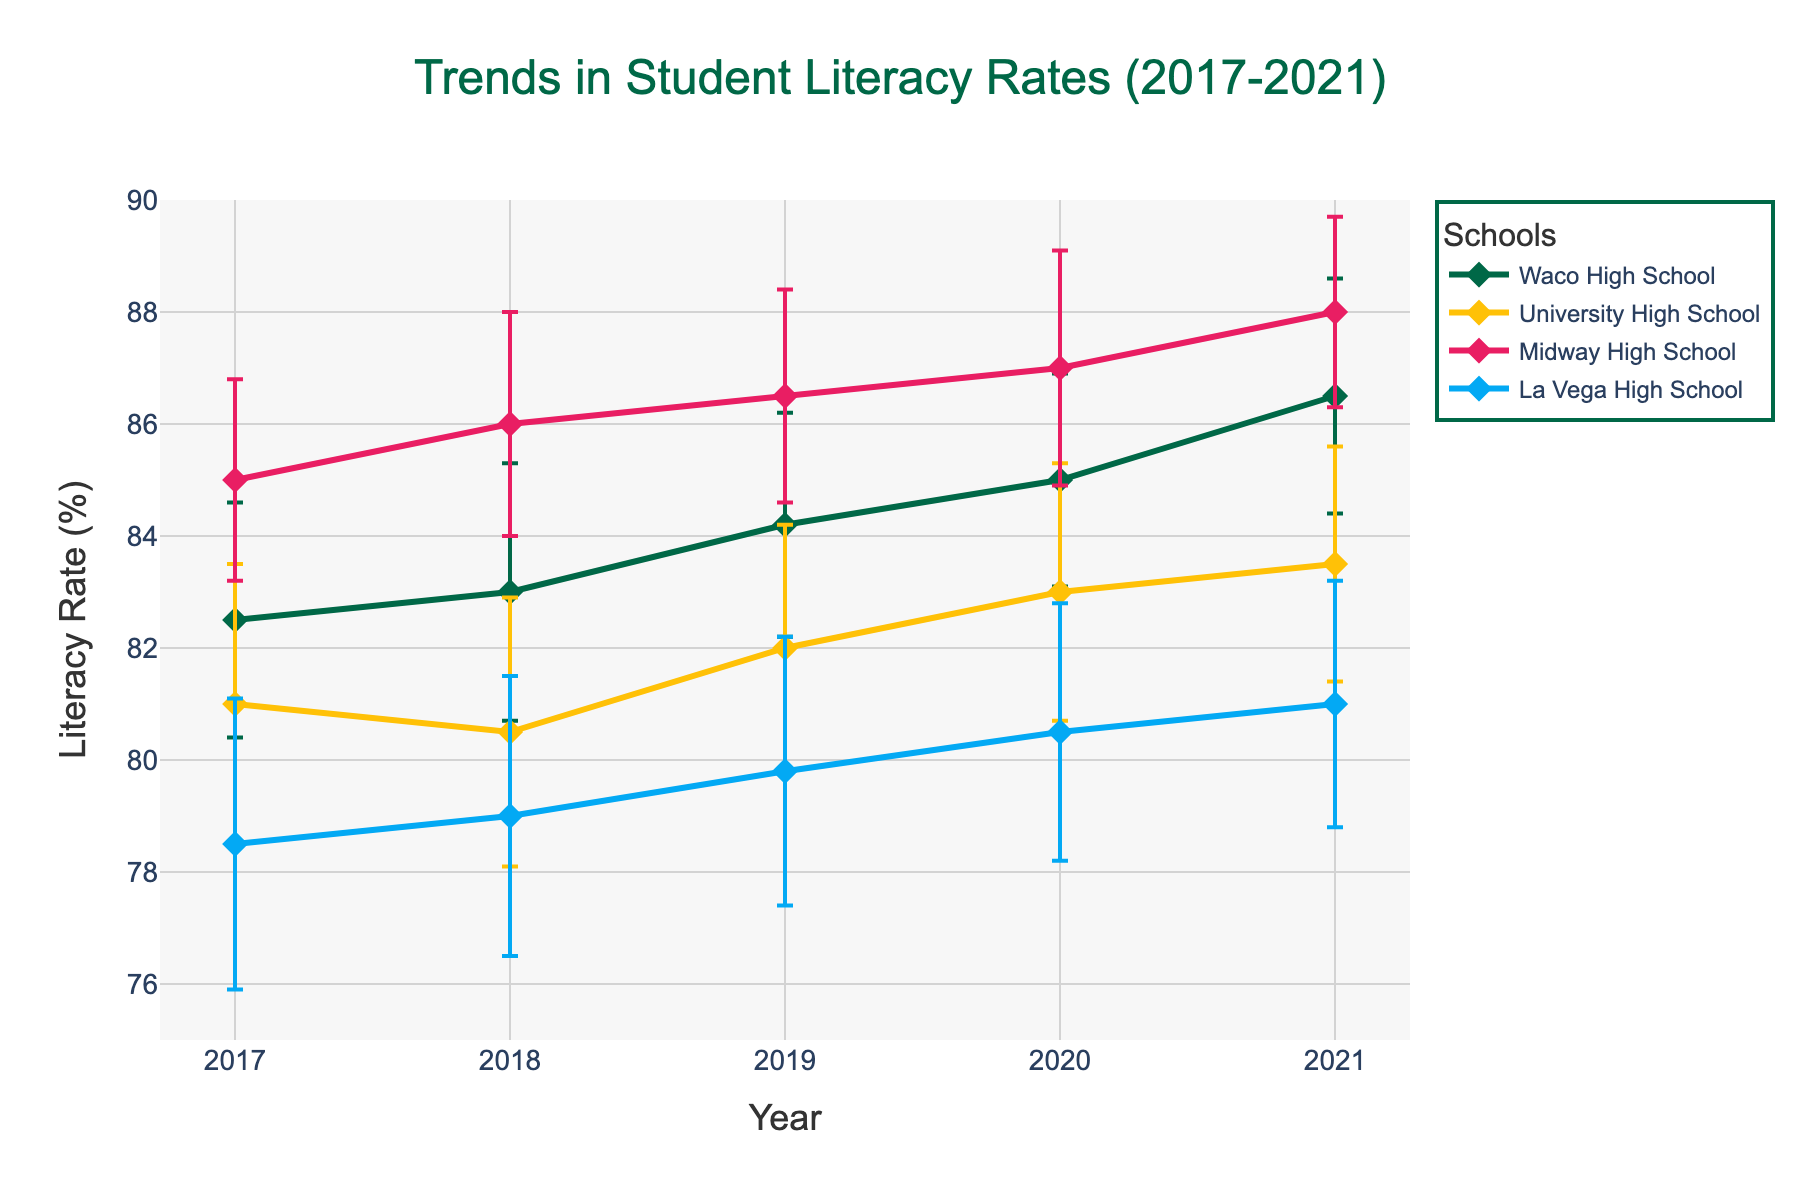How many years of data does the figure cover? The x-axis ranges from 2017 to 2021. That's a span of 5 years.
Answer: 5 years Which school had the highest literacy rate in 2021? By looking at the endpoints of the lines in 2021, Midway High School had the highest literacy rate.
Answer: Midway High School What is the range of the literacy rates for Waco High School from 2017 to 2021? The lowest literacy rate for Waco High School is 82.5% in 2017 and the highest is 86.5% in 2021. The range is 86.5 - 82.5 = 4%.
Answer: 4% Which school had the most consistent literacy rates from 2017 to 2021? Consistency can be assessed by examining the error bars. The school with the smallest standard deviations, which indicates consistency, is Midway High School.
Answer: Midway High School Which school showed the most improvement in literacy rates from 2017 to 2021? To determine improvement, look at the difference between the literacy rates in 2021 and 2017 for each school: 
Waco High School: 86.5 - 82.5 = 4%
University High School: 83.5 - 81.0 = 2.5%
Midway High School: 88.0 - 85.0 = 3%
La Vega High School: 81.0 - 78.5 = 2.5%
The highest increase is by Waco High School with 4%.
Answer: Waco High School In which year did the literacy rates have the least variance across all schools? Variance can be visually estimated by comparing the lengths of the error bars for all schools in each year. 2021 seems to have the shortest error bars overall, indicating the least variance.
Answer: 2021 Did any school have a decreasing trend in literacy rates from 2017 to 2021? By observing the lines, none of the schools show a decreasing trend; they all either increase or remain relatively constant.
Answer: No How did the literacy rate of University High School change between 2017 and 2018? The literacy rate for University High School decreased from 81.0% in 2017 to 80.5% in 2018. The change is 81.0 - 80.5 = -0.5%.
Answer: -0.5% What is the average literacy rate for Midway High School over the five years? The average is calculated by adding all the rates from 2017 to 2021 and dividing by the number of years: (85.0 + 86.0 + 86.5 + 87.0 + 88.0) / 5 = 86.5%.
Answer: 86.5% 